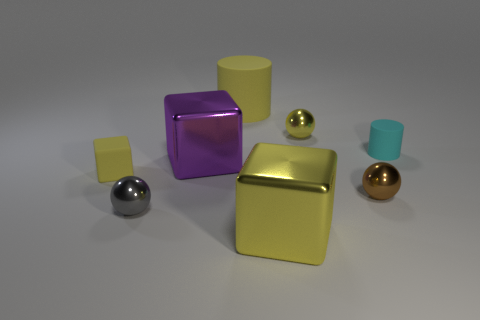Add 1 tiny green matte cylinders. How many objects exist? 9 Subtract all metal blocks. How many blocks are left? 1 Subtract all yellow balls. How many yellow blocks are left? 2 Subtract all cylinders. How many objects are left? 6 Subtract all cyan cylinders. How many cylinders are left? 1 Subtract 1 yellow spheres. How many objects are left? 7 Subtract all brown blocks. Subtract all cyan cylinders. How many blocks are left? 3 Subtract all cyan matte cylinders. Subtract all yellow rubber cylinders. How many objects are left? 6 Add 4 small gray shiny objects. How many small gray shiny objects are left? 5 Add 4 large cylinders. How many large cylinders exist? 5 